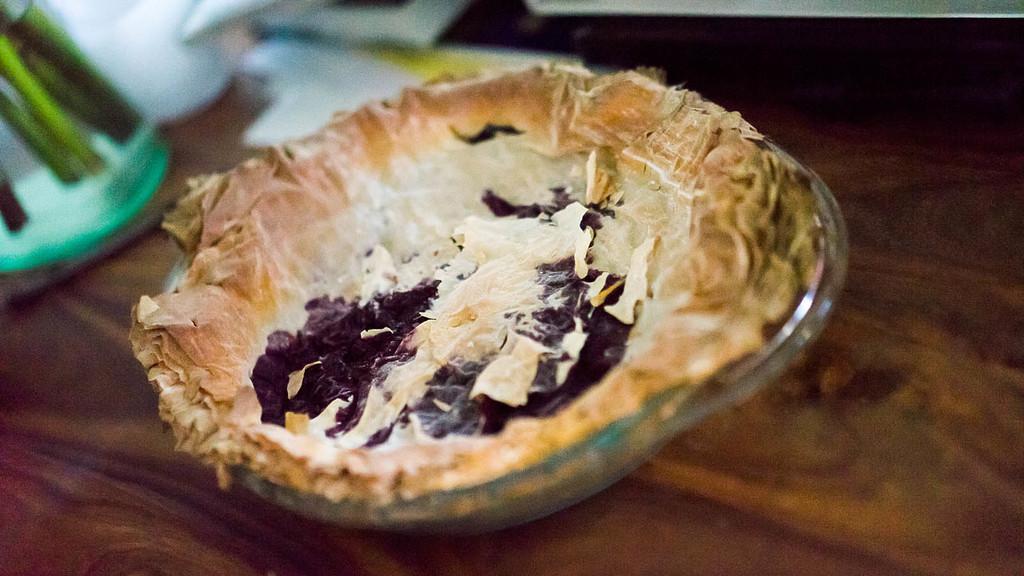Please provide a concise description of this image. In this image I see the bowl on which there is a thing which is of dark purple, white and cream in color and I see the brown color surface and I see that it is blurred in the background and I see white color things over here. 